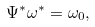Convert formula to latex. <formula><loc_0><loc_0><loc_500><loc_500>\Psi ^ { * } \omega ^ { * } = \omega _ { 0 } ,</formula> 